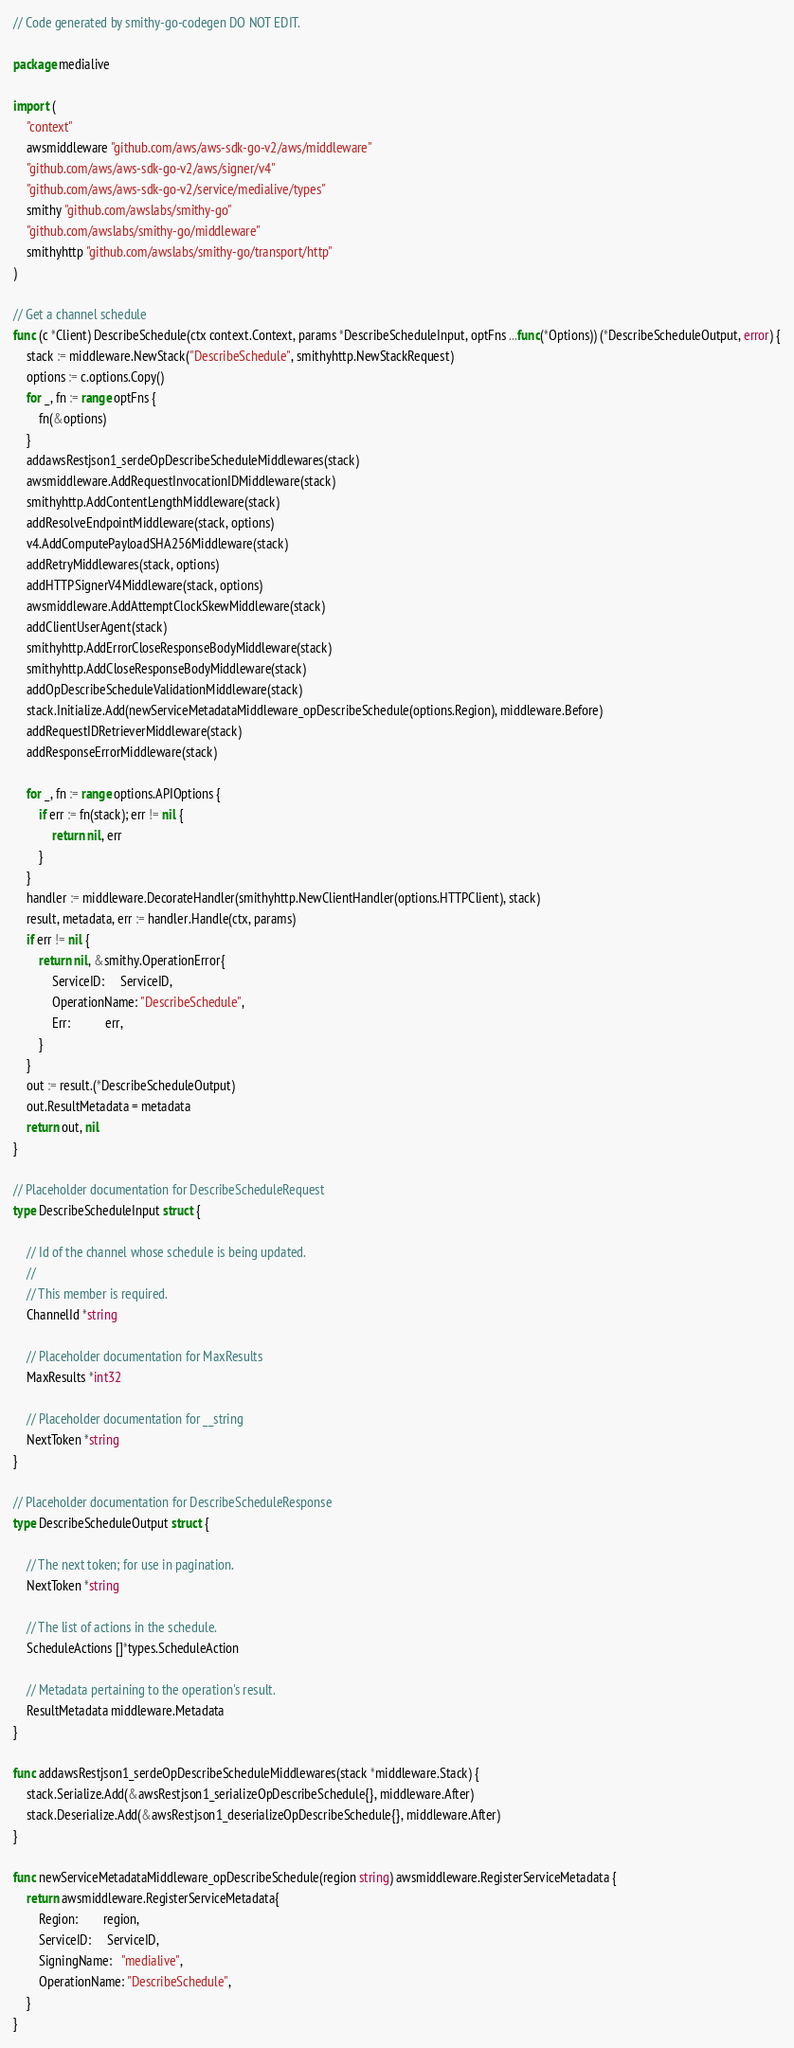<code> <loc_0><loc_0><loc_500><loc_500><_Go_>// Code generated by smithy-go-codegen DO NOT EDIT.

package medialive

import (
	"context"
	awsmiddleware "github.com/aws/aws-sdk-go-v2/aws/middleware"
	"github.com/aws/aws-sdk-go-v2/aws/signer/v4"
	"github.com/aws/aws-sdk-go-v2/service/medialive/types"
	smithy "github.com/awslabs/smithy-go"
	"github.com/awslabs/smithy-go/middleware"
	smithyhttp "github.com/awslabs/smithy-go/transport/http"
)

// Get a channel schedule
func (c *Client) DescribeSchedule(ctx context.Context, params *DescribeScheduleInput, optFns ...func(*Options)) (*DescribeScheduleOutput, error) {
	stack := middleware.NewStack("DescribeSchedule", smithyhttp.NewStackRequest)
	options := c.options.Copy()
	for _, fn := range optFns {
		fn(&options)
	}
	addawsRestjson1_serdeOpDescribeScheduleMiddlewares(stack)
	awsmiddleware.AddRequestInvocationIDMiddleware(stack)
	smithyhttp.AddContentLengthMiddleware(stack)
	addResolveEndpointMiddleware(stack, options)
	v4.AddComputePayloadSHA256Middleware(stack)
	addRetryMiddlewares(stack, options)
	addHTTPSignerV4Middleware(stack, options)
	awsmiddleware.AddAttemptClockSkewMiddleware(stack)
	addClientUserAgent(stack)
	smithyhttp.AddErrorCloseResponseBodyMiddleware(stack)
	smithyhttp.AddCloseResponseBodyMiddleware(stack)
	addOpDescribeScheduleValidationMiddleware(stack)
	stack.Initialize.Add(newServiceMetadataMiddleware_opDescribeSchedule(options.Region), middleware.Before)
	addRequestIDRetrieverMiddleware(stack)
	addResponseErrorMiddleware(stack)

	for _, fn := range options.APIOptions {
		if err := fn(stack); err != nil {
			return nil, err
		}
	}
	handler := middleware.DecorateHandler(smithyhttp.NewClientHandler(options.HTTPClient), stack)
	result, metadata, err := handler.Handle(ctx, params)
	if err != nil {
		return nil, &smithy.OperationError{
			ServiceID:     ServiceID,
			OperationName: "DescribeSchedule",
			Err:           err,
		}
	}
	out := result.(*DescribeScheduleOutput)
	out.ResultMetadata = metadata
	return out, nil
}

// Placeholder documentation for DescribeScheduleRequest
type DescribeScheduleInput struct {

	// Id of the channel whose schedule is being updated.
	//
	// This member is required.
	ChannelId *string

	// Placeholder documentation for MaxResults
	MaxResults *int32

	// Placeholder documentation for __string
	NextToken *string
}

// Placeholder documentation for DescribeScheduleResponse
type DescribeScheduleOutput struct {

	// The next token; for use in pagination.
	NextToken *string

	// The list of actions in the schedule.
	ScheduleActions []*types.ScheduleAction

	// Metadata pertaining to the operation's result.
	ResultMetadata middleware.Metadata
}

func addawsRestjson1_serdeOpDescribeScheduleMiddlewares(stack *middleware.Stack) {
	stack.Serialize.Add(&awsRestjson1_serializeOpDescribeSchedule{}, middleware.After)
	stack.Deserialize.Add(&awsRestjson1_deserializeOpDescribeSchedule{}, middleware.After)
}

func newServiceMetadataMiddleware_opDescribeSchedule(region string) awsmiddleware.RegisterServiceMetadata {
	return awsmiddleware.RegisterServiceMetadata{
		Region:        region,
		ServiceID:     ServiceID,
		SigningName:   "medialive",
		OperationName: "DescribeSchedule",
	}
}
</code> 